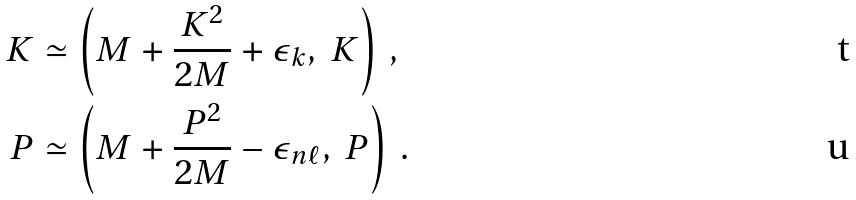<formula> <loc_0><loc_0><loc_500><loc_500>K & \simeq \left ( M + \frac { { K } ^ { 2 } } { 2 M } + \epsilon _ { k } , \ { K } \right ) \, , \\ P & \simeq \left ( M + \frac { { P } ^ { 2 } } { 2 M } - \epsilon _ { n \ell } , \ { P } \right ) \, .</formula> 